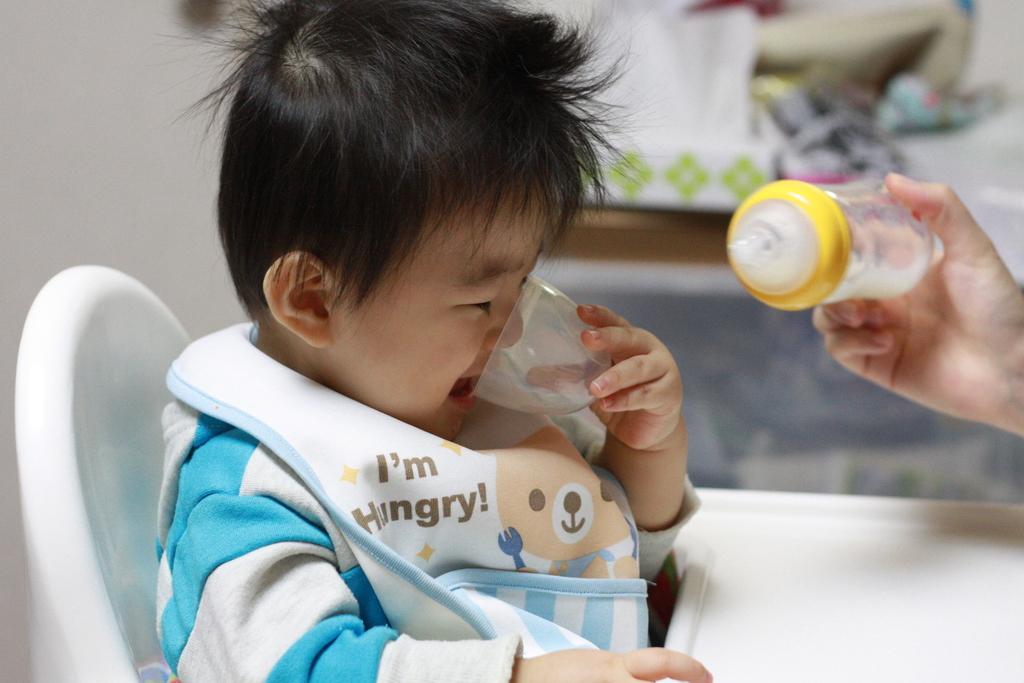What does the bib say?
Your answer should be compact. I'm hungry. What animal is on the bib?
Ensure brevity in your answer.  Answering does not require reading text in the image. 